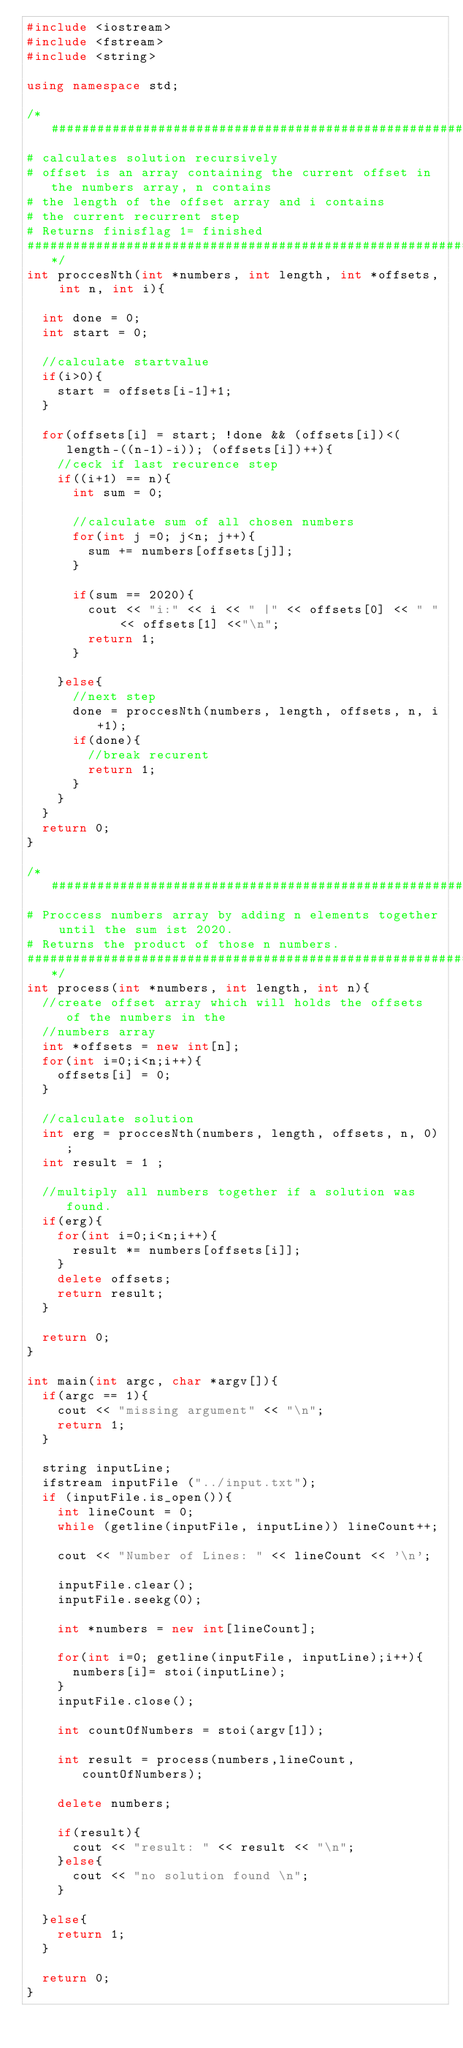Convert code to text. <code><loc_0><loc_0><loc_500><loc_500><_C++_>#include <iostream>
#include <fstream>
#include <string>

using namespace std;

/*##############################################################################
# calculates solution recursively
# offset is an array containing the current offset in the numbers array, n contains 
# the length of the offset array and i contains 
# the current recurrent step
# Returns finisflag 1= finished
##############################################################################*/
int proccesNth(int *numbers, int length, int *offsets, int n, int i){
	
	int done = 0;
	int start = 0;

	//calculate startvalue 
	if(i>0){
		start = offsets[i-1]+1;
	}
	
	for(offsets[i] = start; !done && (offsets[i])<(length-((n-1)-i)); (offsets[i])++){
		//ceck if last recurence step
		if((i+1) == n){
			int sum = 0;
			
			//calculate sum of all chosen numbers
			for(int j =0; j<n; j++){
				sum += numbers[offsets[j]];
			}

			if(sum == 2020){
				cout << "i:" << i << " |" << offsets[0] << " " << offsets[1] <<"\n";
				return 1;
			}
			
		}else{
			//next step
			done = proccesNth(numbers, length, offsets, n, i+1);
			if(done){
				//break recurent
				return 1;
			}
		}
	}
	return 0;
}

/*##############################################################################
# Proccess numbers array by adding n elements together until the sum ist 2020.
# Returns the product of those n numbers.
##############################################################################*/
int process(int *numbers, int length, int n){
	//create offset array which will holds the offsets of the numbers in the 
	//numbers array
	int *offsets = new int[n];
	for(int i=0;i<n;i++){
		offsets[i] = 0;
	}

	//calculate solution
	int erg = proccesNth(numbers, length, offsets, n, 0);
	int result = 1 ;

	//multiply all numbers together if a solution was found.
	if(erg){
		for(int i=0;i<n;i++){
			result *= numbers[offsets[i]];
		}
		delete offsets;
		return result;
	}

	return 0;
}

int main(int argc, char *argv[]){
	if(argc == 1){
		cout << "missing argument" << "\n";
		return 1;
	}

	string inputLine;
	ifstream inputFile ("../input.txt");
	if (inputFile.is_open()){
		int lineCount = 0;
		while (getline(inputFile, inputLine)) lineCount++;

		cout << "Number of Lines: " << lineCount << '\n';

		inputFile.clear();
		inputFile.seekg(0);

		int *numbers = new int[lineCount];

		for(int i=0; getline(inputFile, inputLine);i++){
			numbers[i]= stoi(inputLine);
		}
		inputFile.close();

		int countOfNumbers = stoi(argv[1]);

		int result = process(numbers,lineCount,countOfNumbers);

		delete numbers;

		if(result){
			cout << "result: " << result << "\n";
		}else{
			cout << "no solution found \n";
		}

	}else{
		return 1;
	}

	return 0;
}</code> 